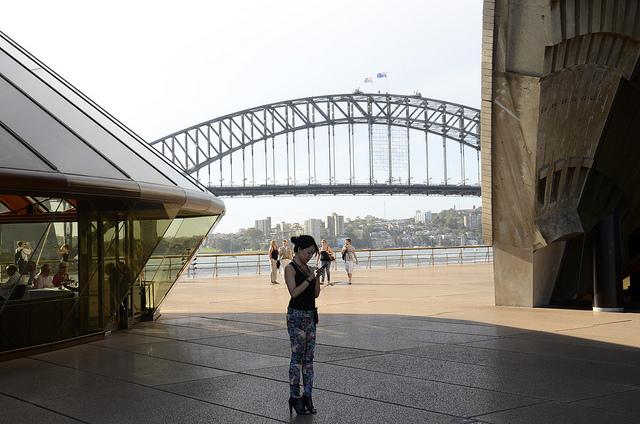Is the girl standing in the sun?
Be succinct. No. Is this a tourist place?
Answer briefly. Yes. Is there a plane in the sky?
Be succinct. No. 